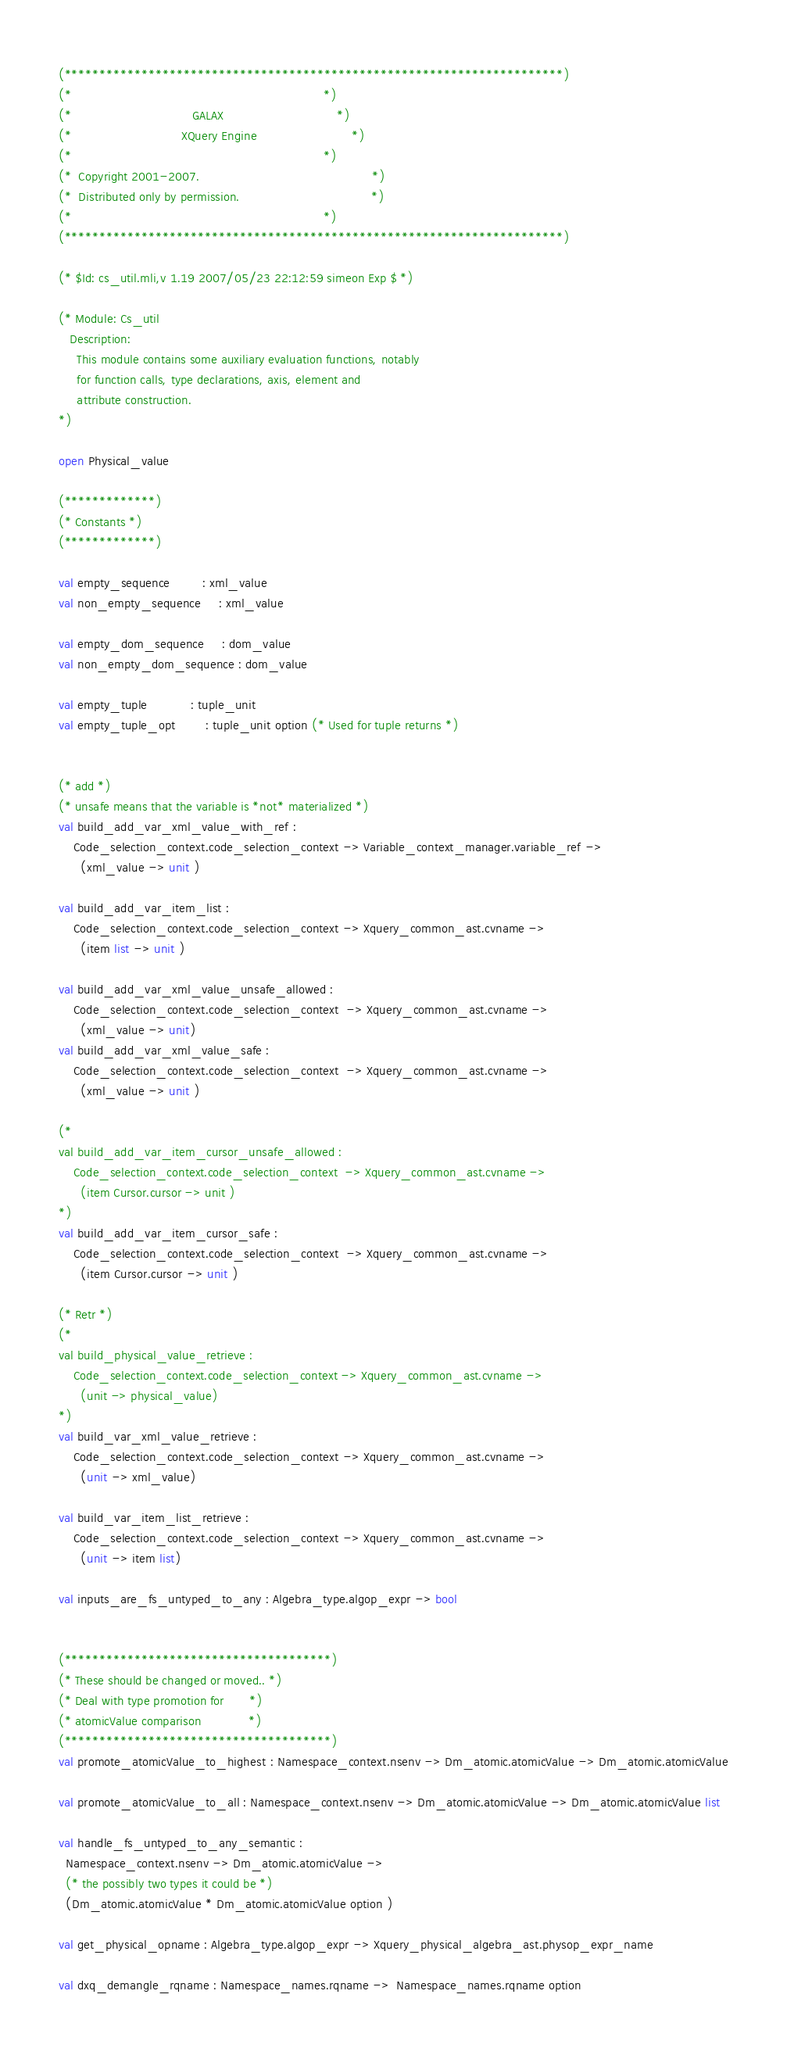<code> <loc_0><loc_0><loc_500><loc_500><_OCaml_>(***********************************************************************)
(*                                                                     *)
(*                                 GALAX                               *)
(*                              XQuery Engine                          *)
(*                                                                     *)
(*  Copyright 2001-2007.                                               *)
(*  Distributed only by permission.                                    *)
(*                                                                     *)
(***********************************************************************)

(* $Id: cs_util.mli,v 1.19 2007/05/23 22:12:59 simeon Exp $ *)

(* Module: Cs_util
   Description:
     This module contains some auxiliary evaluation functions, notably
     for function calls, type declarations, axis, element and
     attribute construction.
*)

open Physical_value

(*************)
(* Constants *)
(*************)

val empty_sequence         : xml_value
val non_empty_sequence     : xml_value 

val empty_dom_sequence     : dom_value
val non_empty_dom_sequence : dom_value 

val empty_tuple            : tuple_unit
val empty_tuple_opt        : tuple_unit option (* Used for tuple returns *)


(* add *)
(* unsafe means that the variable is *not* materialized *)
val build_add_var_xml_value_with_ref :
    Code_selection_context.code_selection_context -> Variable_context_manager.variable_ref -> 
      (xml_value -> unit )

val build_add_var_item_list :
    Code_selection_context.code_selection_context -> Xquery_common_ast.cvname -> 
      (item list -> unit )

val build_add_var_xml_value_unsafe_allowed :
    Code_selection_context.code_selection_context  -> Xquery_common_ast.cvname -> 
      (xml_value -> unit)
val build_add_var_xml_value_safe :
    Code_selection_context.code_selection_context  -> Xquery_common_ast.cvname -> 
      (xml_value -> unit )

(*
val build_add_var_item_cursor_unsafe_allowed :
    Code_selection_context.code_selection_context  -> Xquery_common_ast.cvname -> 
      (item Cursor.cursor -> unit )
*)
val build_add_var_item_cursor_safe :
    Code_selection_context.code_selection_context  -> Xquery_common_ast.cvname -> 
      (item Cursor.cursor -> unit )

(* Retr *)
(*
val build_physical_value_retrieve :
    Code_selection_context.code_selection_context -> Xquery_common_ast.cvname -> 
      (unit -> physical_value)
*)
val build_var_xml_value_retrieve :
    Code_selection_context.code_selection_context -> Xquery_common_ast.cvname -> 
      (unit -> xml_value)

val build_var_item_list_retrieve :
    Code_selection_context.code_selection_context -> Xquery_common_ast.cvname -> 
      (unit -> item list)

val inputs_are_fs_untyped_to_any : Algebra_type.algop_expr -> bool


(**************************************)
(* These should be changed or moved.. *)
(* Deal with type promotion for       *)
(* atomicValue comparison             *)
(**************************************)
val promote_atomicValue_to_highest : Namespace_context.nsenv -> Dm_atomic.atomicValue -> Dm_atomic.atomicValue

val promote_atomicValue_to_all : Namespace_context.nsenv -> Dm_atomic.atomicValue -> Dm_atomic.atomicValue list

val handle_fs_untyped_to_any_semantic : 
  Namespace_context.nsenv -> Dm_atomic.atomicValue -> 
  (* the possibly two types it could be *)
  (Dm_atomic.atomicValue * Dm_atomic.atomicValue option )

val get_physical_opname : Algebra_type.algop_expr -> Xquery_physical_algebra_ast.physop_expr_name

val dxq_demangle_rqname : Namespace_names.rqname ->  Namespace_names.rqname option
</code> 